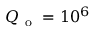<formula> <loc_0><loc_0><loc_500><loc_500>Q _ { o } = 1 0 ^ { 6 }</formula> 